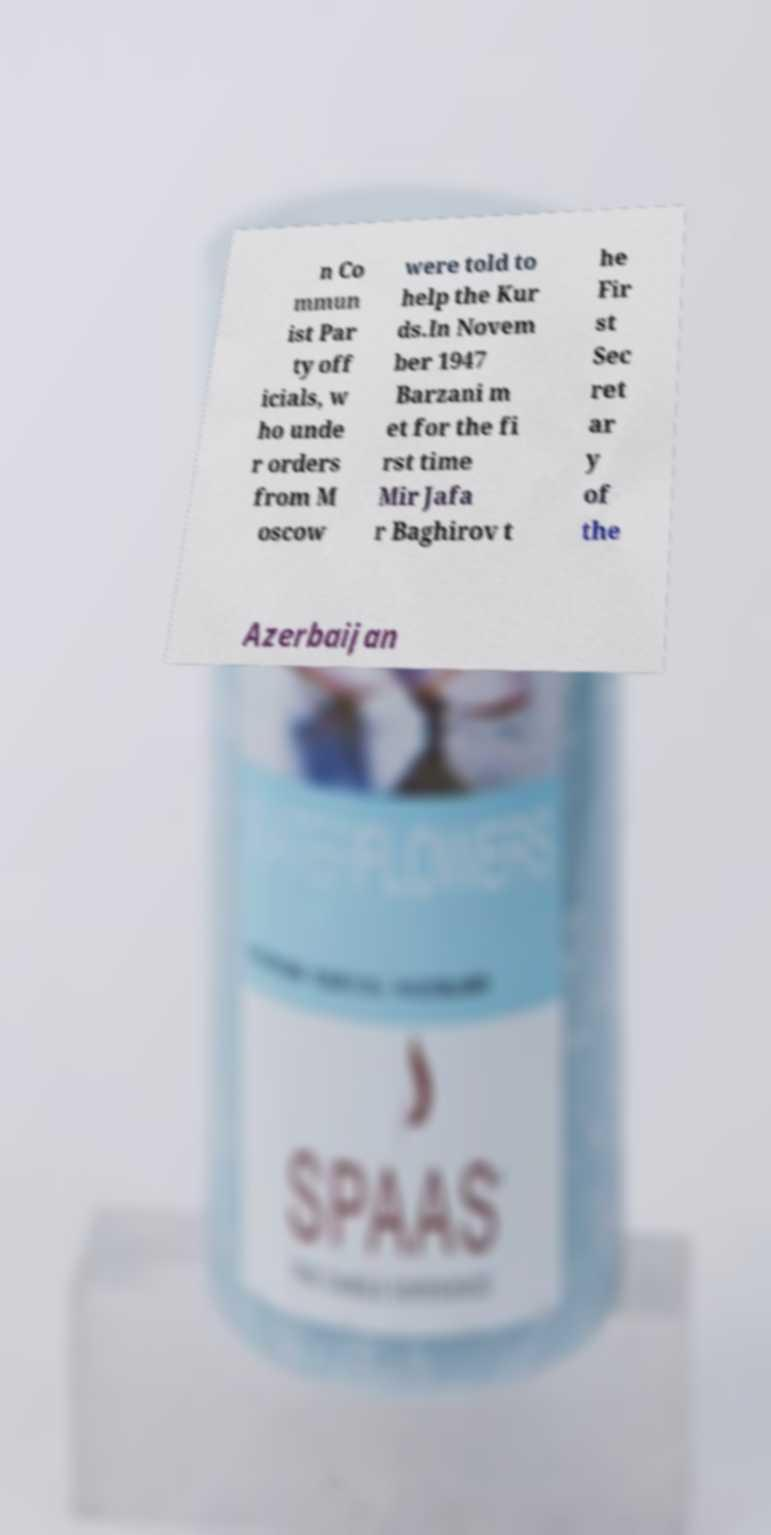Can you accurately transcribe the text from the provided image for me? n Co mmun ist Par ty off icials, w ho unde r orders from M oscow were told to help the Kur ds.In Novem ber 1947 Barzani m et for the fi rst time Mir Jafa r Baghirov t he Fir st Sec ret ar y of the Azerbaijan 